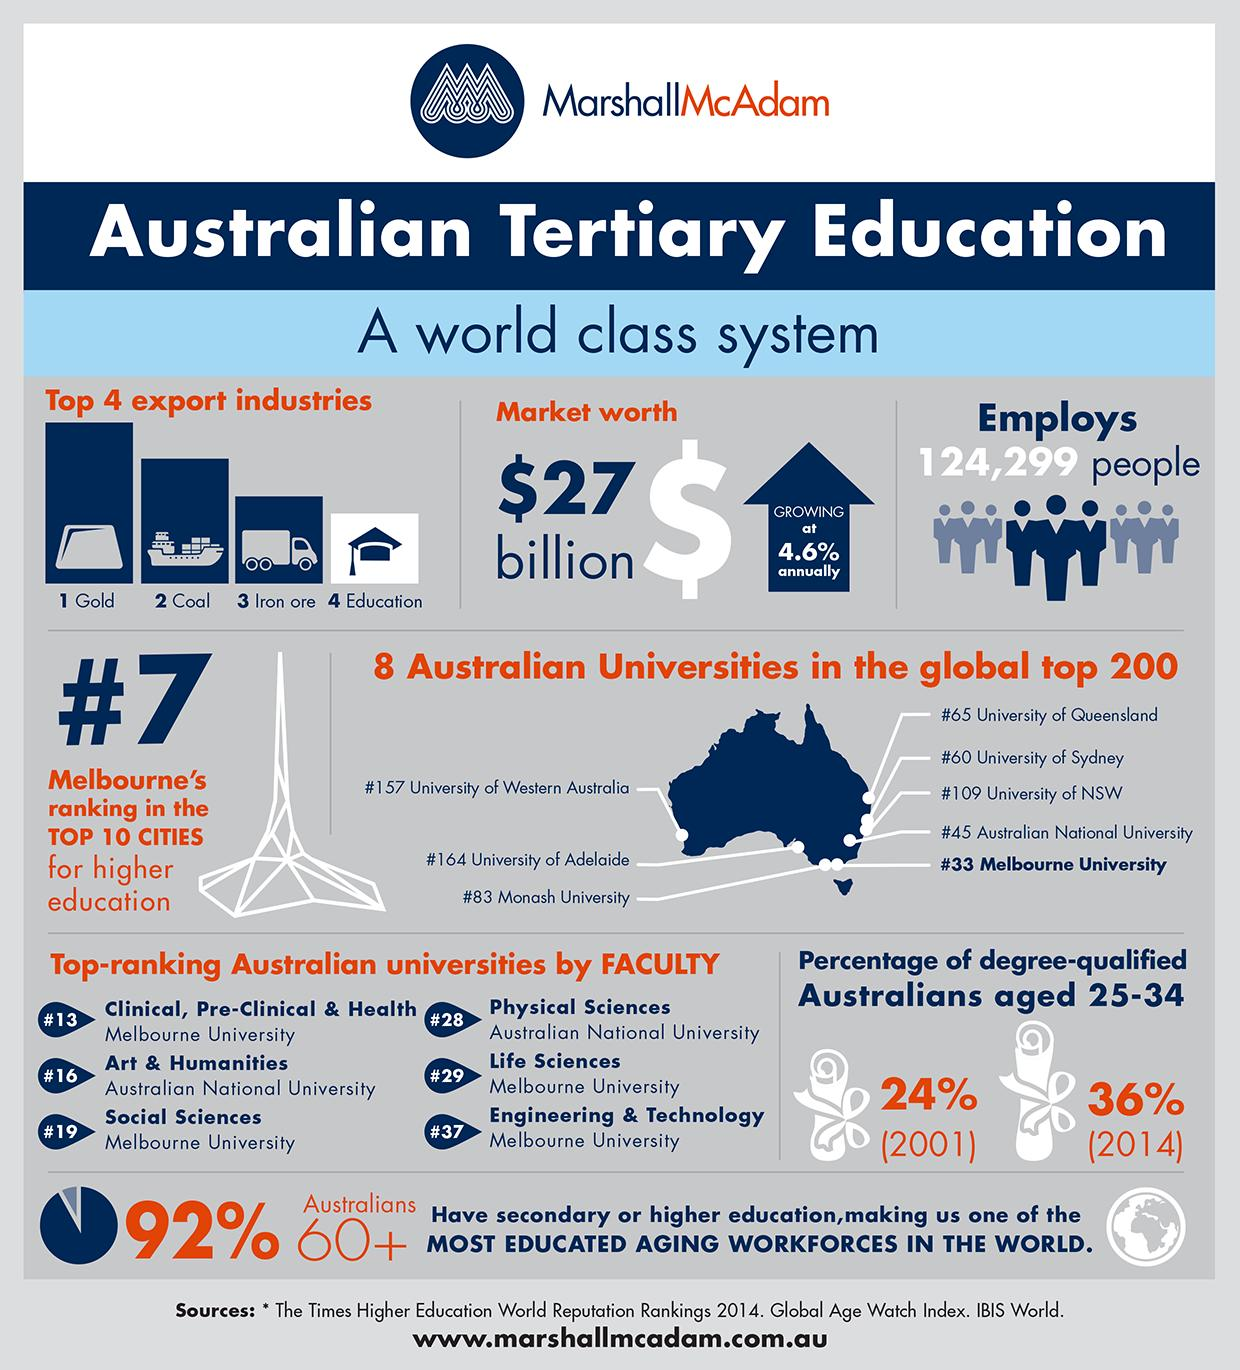Draw attention to some important aspects in this diagram. In 2014, the percentage of Australians who gained degrees increased by 12% compared to 2001. 